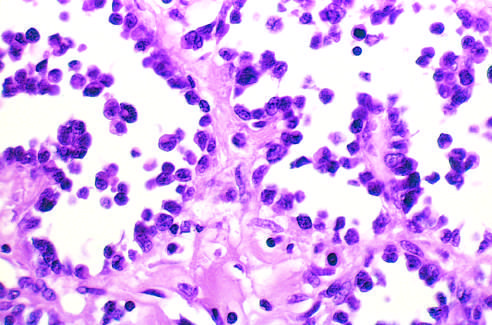how is alveolar rhabdomyosarcoma with numerous spaces lined?
Answer the question using a single word or phrase. With discohesive 